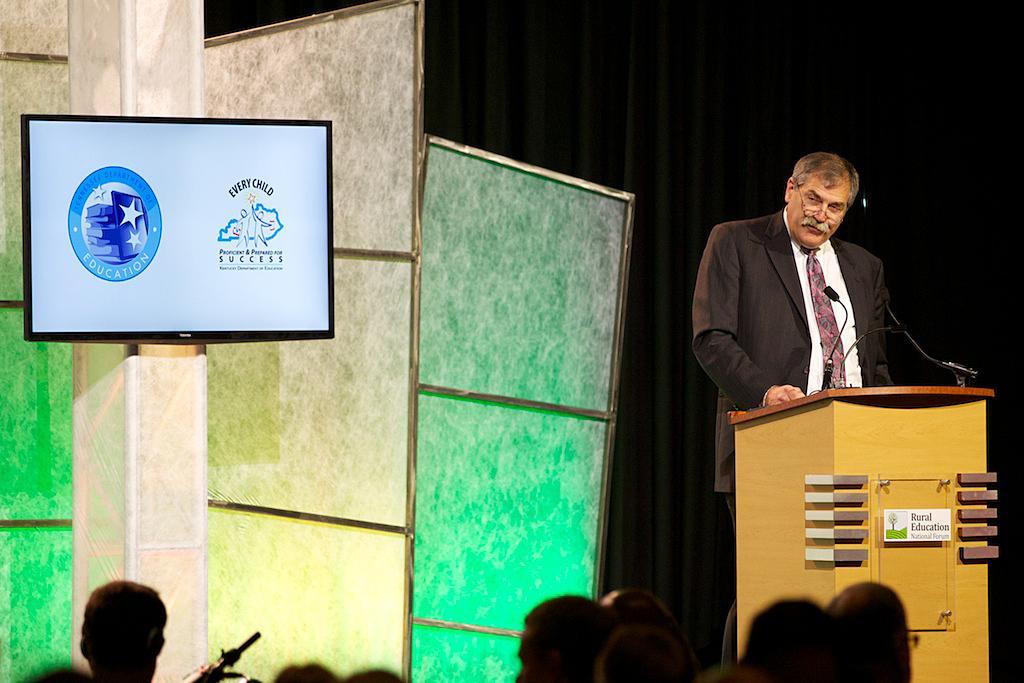Could you give a brief overview of what you see in this image? In this picture we can see a man wearing spectacles, white shirt, tie and a blazer standing near to a podium. This is a screen. 